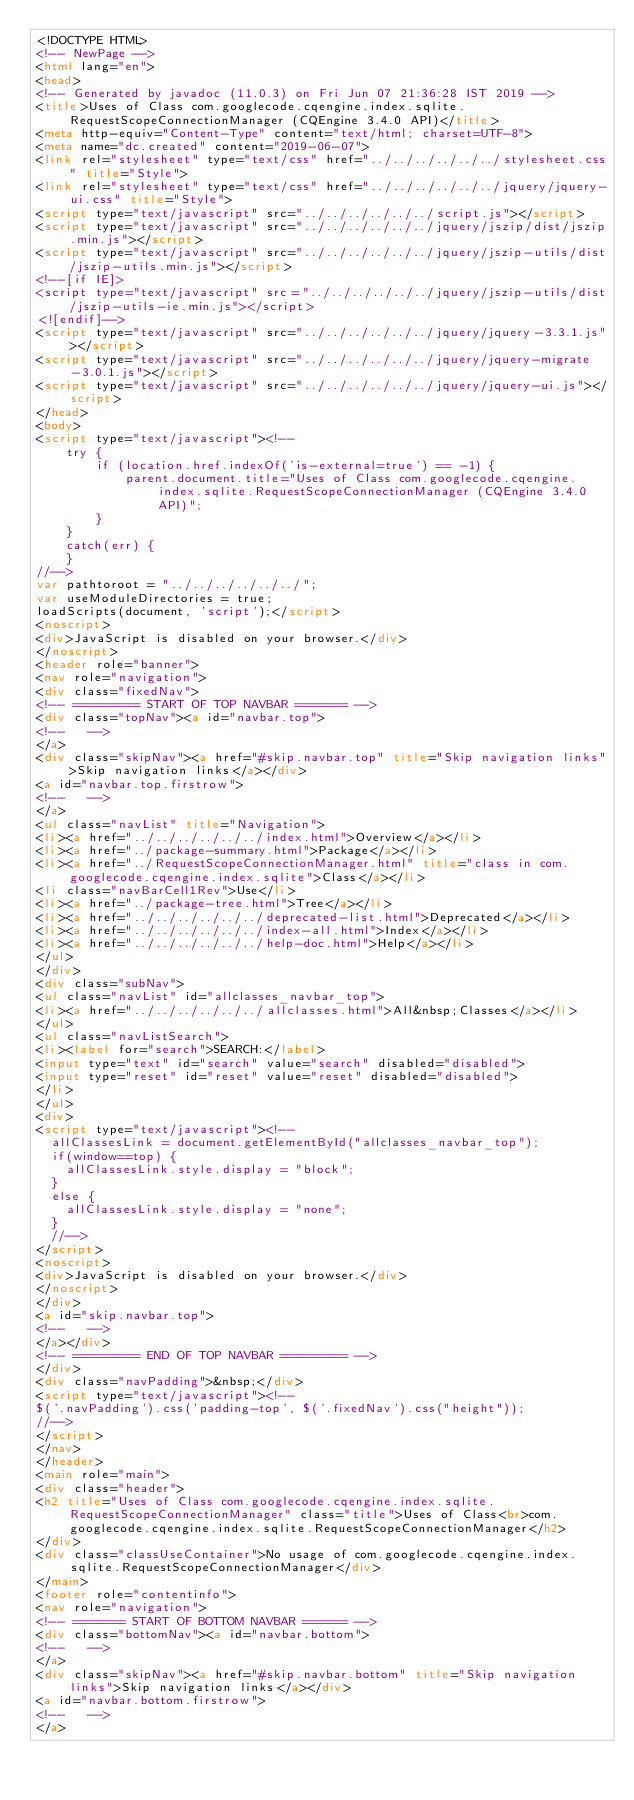<code> <loc_0><loc_0><loc_500><loc_500><_HTML_><!DOCTYPE HTML>
<!-- NewPage -->
<html lang="en">
<head>
<!-- Generated by javadoc (11.0.3) on Fri Jun 07 21:36:28 IST 2019 -->
<title>Uses of Class com.googlecode.cqengine.index.sqlite.RequestScopeConnectionManager (CQEngine 3.4.0 API)</title>
<meta http-equiv="Content-Type" content="text/html; charset=UTF-8">
<meta name="dc.created" content="2019-06-07">
<link rel="stylesheet" type="text/css" href="../../../../../../stylesheet.css" title="Style">
<link rel="stylesheet" type="text/css" href="../../../../../../jquery/jquery-ui.css" title="Style">
<script type="text/javascript" src="../../../../../../script.js"></script>
<script type="text/javascript" src="../../../../../../jquery/jszip/dist/jszip.min.js"></script>
<script type="text/javascript" src="../../../../../../jquery/jszip-utils/dist/jszip-utils.min.js"></script>
<!--[if IE]>
<script type="text/javascript" src="../../../../../../jquery/jszip-utils/dist/jszip-utils-ie.min.js"></script>
<![endif]-->
<script type="text/javascript" src="../../../../../../jquery/jquery-3.3.1.js"></script>
<script type="text/javascript" src="../../../../../../jquery/jquery-migrate-3.0.1.js"></script>
<script type="text/javascript" src="../../../../../../jquery/jquery-ui.js"></script>
</head>
<body>
<script type="text/javascript"><!--
    try {
        if (location.href.indexOf('is-external=true') == -1) {
            parent.document.title="Uses of Class com.googlecode.cqengine.index.sqlite.RequestScopeConnectionManager (CQEngine 3.4.0 API)";
        }
    }
    catch(err) {
    }
//-->
var pathtoroot = "../../../../../../";
var useModuleDirectories = true;
loadScripts(document, 'script');</script>
<noscript>
<div>JavaScript is disabled on your browser.</div>
</noscript>
<header role="banner">
<nav role="navigation">
<div class="fixedNav">
<!-- ========= START OF TOP NAVBAR ======= -->
<div class="topNav"><a id="navbar.top">
<!--   -->
</a>
<div class="skipNav"><a href="#skip.navbar.top" title="Skip navigation links">Skip navigation links</a></div>
<a id="navbar.top.firstrow">
<!--   -->
</a>
<ul class="navList" title="Navigation">
<li><a href="../../../../../../index.html">Overview</a></li>
<li><a href="../package-summary.html">Package</a></li>
<li><a href="../RequestScopeConnectionManager.html" title="class in com.googlecode.cqengine.index.sqlite">Class</a></li>
<li class="navBarCell1Rev">Use</li>
<li><a href="../package-tree.html">Tree</a></li>
<li><a href="../../../../../../deprecated-list.html">Deprecated</a></li>
<li><a href="../../../../../../index-all.html">Index</a></li>
<li><a href="../../../../../../help-doc.html">Help</a></li>
</ul>
</div>
<div class="subNav">
<ul class="navList" id="allclasses_navbar_top">
<li><a href="../../../../../../allclasses.html">All&nbsp;Classes</a></li>
</ul>
<ul class="navListSearch">
<li><label for="search">SEARCH:</label>
<input type="text" id="search" value="search" disabled="disabled">
<input type="reset" id="reset" value="reset" disabled="disabled">
</li>
</ul>
<div>
<script type="text/javascript"><!--
  allClassesLink = document.getElementById("allclasses_navbar_top");
  if(window==top) {
    allClassesLink.style.display = "block";
  }
  else {
    allClassesLink.style.display = "none";
  }
  //-->
</script>
<noscript>
<div>JavaScript is disabled on your browser.</div>
</noscript>
</div>
<a id="skip.navbar.top">
<!--   -->
</a></div>
<!-- ========= END OF TOP NAVBAR ========= -->
</div>
<div class="navPadding">&nbsp;</div>
<script type="text/javascript"><!--
$('.navPadding').css('padding-top', $('.fixedNav').css("height"));
//-->
</script>
</nav>
</header>
<main role="main">
<div class="header">
<h2 title="Uses of Class com.googlecode.cqengine.index.sqlite.RequestScopeConnectionManager" class="title">Uses of Class<br>com.googlecode.cqengine.index.sqlite.RequestScopeConnectionManager</h2>
</div>
<div class="classUseContainer">No usage of com.googlecode.cqengine.index.sqlite.RequestScopeConnectionManager</div>
</main>
<footer role="contentinfo">
<nav role="navigation">
<!-- ======= START OF BOTTOM NAVBAR ====== -->
<div class="bottomNav"><a id="navbar.bottom">
<!--   -->
</a>
<div class="skipNav"><a href="#skip.navbar.bottom" title="Skip navigation links">Skip navigation links</a></div>
<a id="navbar.bottom.firstrow">
<!--   -->
</a></code> 